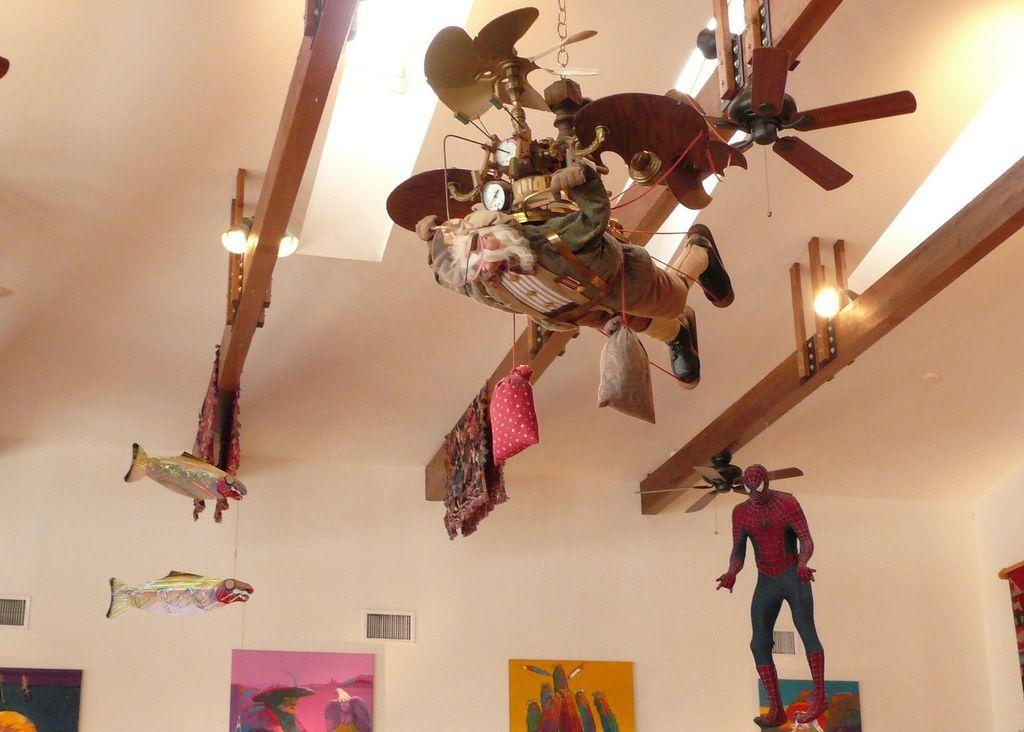What is visible above the scene in the image? There is a ceiling visible in the image. What can be found on the ceiling? There are lights on the ceiling. What type of objects can be seen in the image? There are toys in the image. What is present on the wall in the image? There are pictures on a wall in the image. What type of crime is being committed in the image? There is no crime being committed in the image; it features toys and pictures on a wall. How many competitors are visible in the image? There is no competition or competitors present in the image. 